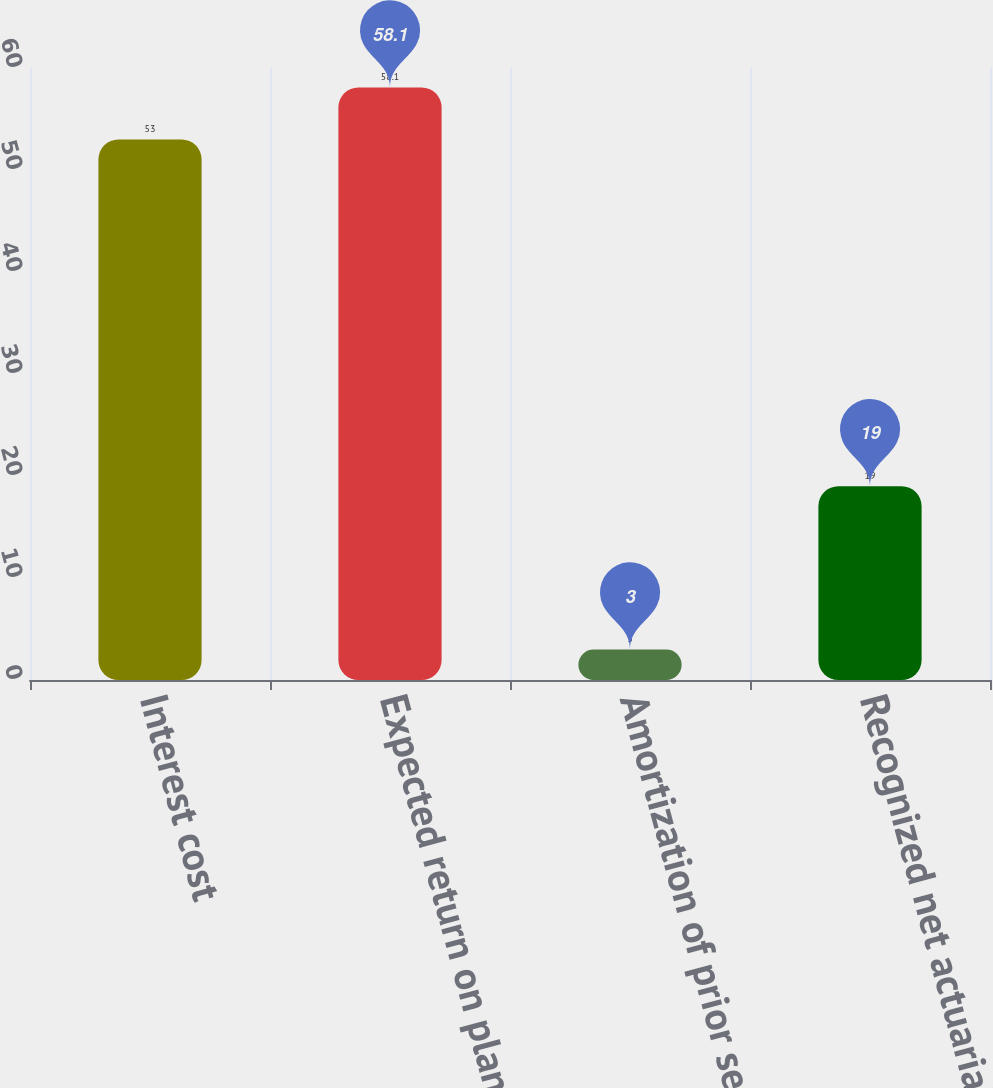Convert chart to OTSL. <chart><loc_0><loc_0><loc_500><loc_500><bar_chart><fcel>Interest cost<fcel>Expected return on plan assets<fcel>Amortization of prior service<fcel>Recognized net actuarial loss<nl><fcel>53<fcel>58.1<fcel>3<fcel>19<nl></chart> 